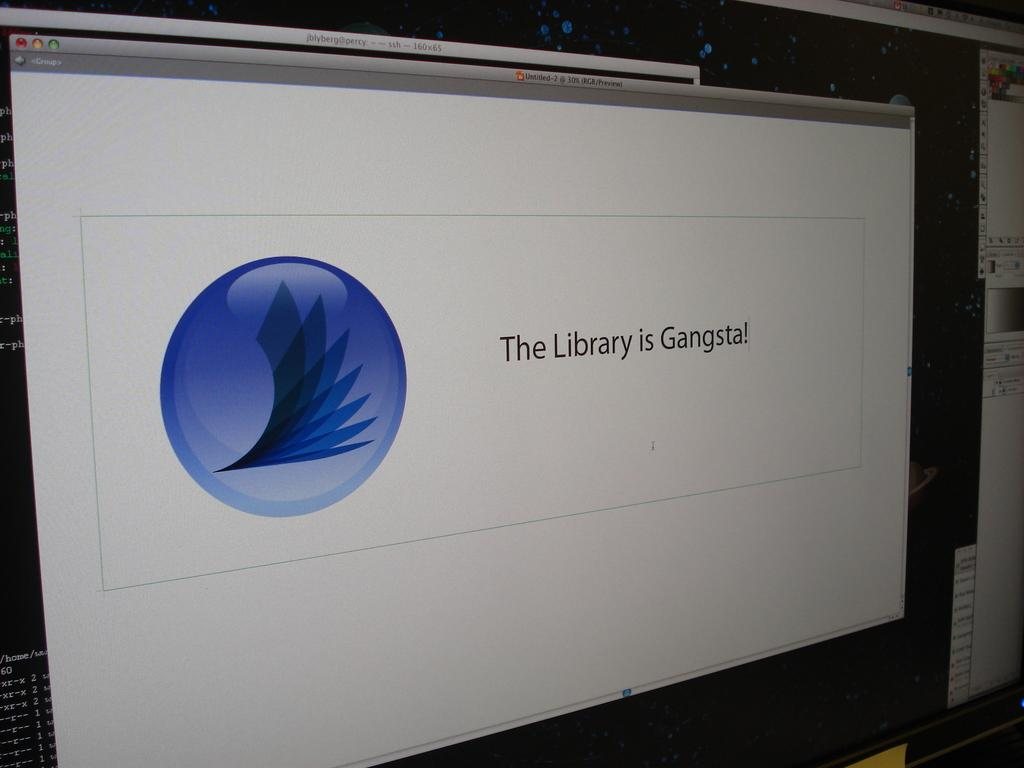<image>
Render a clear and concise summary of the photo. A application pulled up on the computer reading the library is gangsta. 